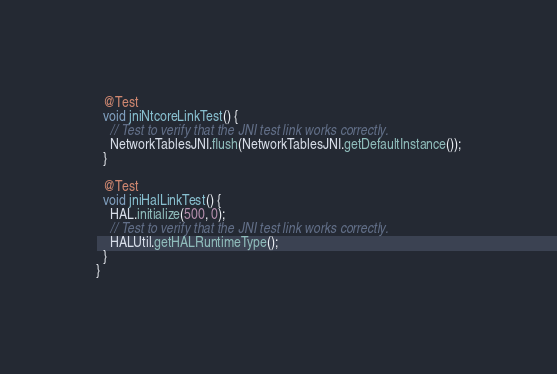<code> <loc_0><loc_0><loc_500><loc_500><_Java_>  @Test
  void jniNtcoreLinkTest() {
    // Test to verify that the JNI test link works correctly.
    NetworkTablesJNI.flush(NetworkTablesJNI.getDefaultInstance());
  }

  @Test
  void jniHalLinkTest() {
    HAL.initialize(500, 0);
    // Test to verify that the JNI test link works correctly.
    HALUtil.getHALRuntimeType();
  }
}
</code> 